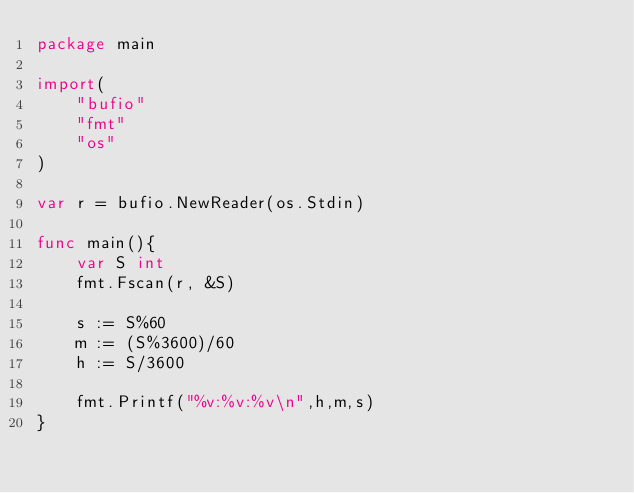Convert code to text. <code><loc_0><loc_0><loc_500><loc_500><_Go_>package main

import(
    "bufio"
    "fmt"
    "os"
)

var r = bufio.NewReader(os.Stdin)

func main(){
    var S int
    fmt.Fscan(r, &S)
    
    s := S%60
    m := (S%3600)/60
    h := S/3600
    
    fmt.Printf("%v:%v:%v\n",h,m,s)
}
</code> 